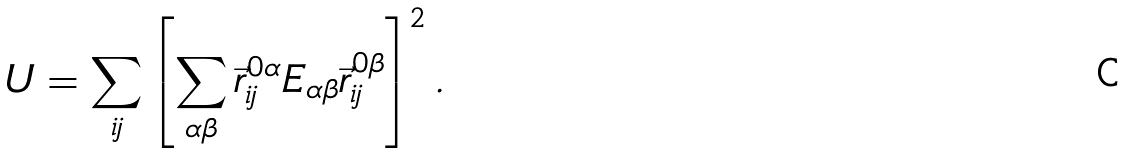<formula> <loc_0><loc_0><loc_500><loc_500>U = \sum _ { i j } \left [ \sum _ { \alpha \beta } \vec { r } ^ { 0 \alpha } _ { i j } E _ { \alpha \beta } \vec { r } ^ { 0 \beta } _ { i j } \right ] ^ { 2 } .</formula> 